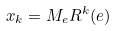Convert formula to latex. <formula><loc_0><loc_0><loc_500><loc_500>x _ { k } = M _ { e } R ^ { k } ( e )</formula> 